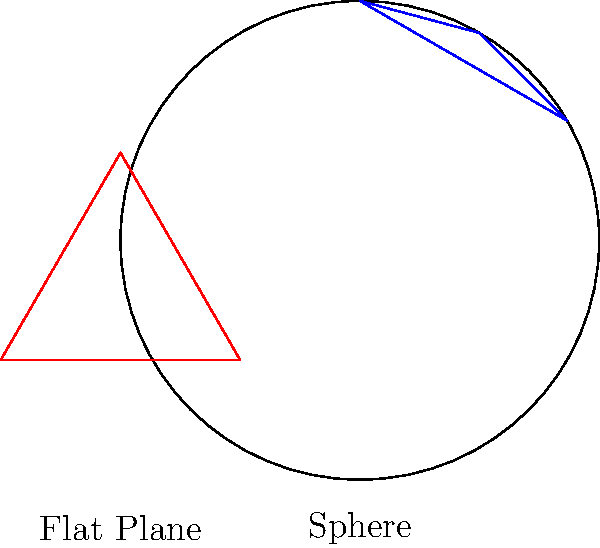As a customer service representative, you often need to explain complex concepts in simple terms. Consider the triangles shown in the image above, one on a sphere (blue) and one on a flat plane (red). How would you explain to a claimant why the sum of the angles in the spherical triangle is greater than 180°, while the sum of the angles in the flat triangle is exactly 180°? To explain this concept to a claimant, we can break it down into simple steps:

1. Flat Triangle:
   - On a flat surface, like a piece of paper, the angles of a triangle always add up to 180°.
   - This is a fundamental rule of Euclidean geometry that we learn in school.

2. Spherical Triangle:
   - On a sphere, the surface is curved, not flat.
   - This curvature affects the behavior of lines and angles on the surface.

3. The Difference:
   - On a sphere, the "straight lines" of a triangle are actually curved (they're parts of great circles).
   - These curved lines cause the angles to be larger than they would be on a flat surface.

4. Mathematical Explanation:
   - The sum of angles in a spherical triangle is given by the formula: $$ \text{Sum} = 180° + \frac{A}{R^2} \times \frac{180°}{\pi} $$
   - Where $A$ is the area of the triangle and $R$ is the radius of the sphere.
   - This means the sum is always greater than 180°.

5. Practical Example:
   - If you draw a triangle on a globe, starting at the equator and going to the North Pole, you can create a triangle with three 90° angles, summing to 270°.
   - This is impossible on a flat surface but perfectly valid on a sphere.

6. Relevance to Customer Service:
   - Understanding this concept can help in explaining why certain geographical or navigational calculations might be different from what a claimant expects, especially for long-distance or global matters.
Answer: Curvature of the sphere increases angle sum beyond 180°. 